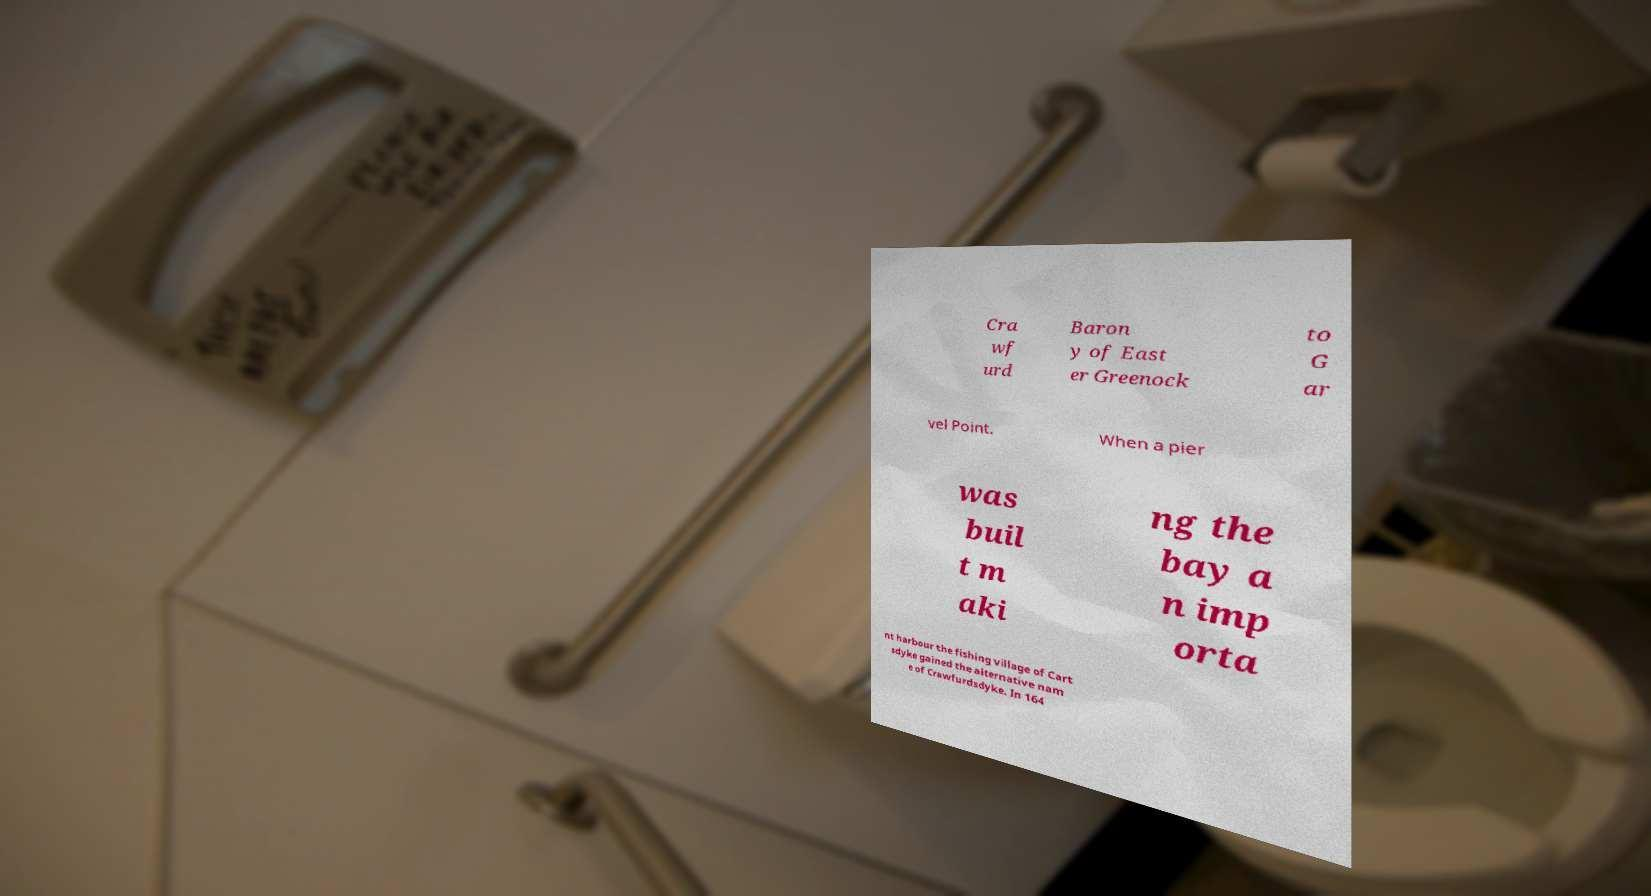Could you assist in decoding the text presented in this image and type it out clearly? Cra wf urd Baron y of East er Greenock to G ar vel Point. When a pier was buil t m aki ng the bay a n imp orta nt harbour the fishing village of Cart sdyke gained the alternative nam e of Crawfurdsdyke. In 164 